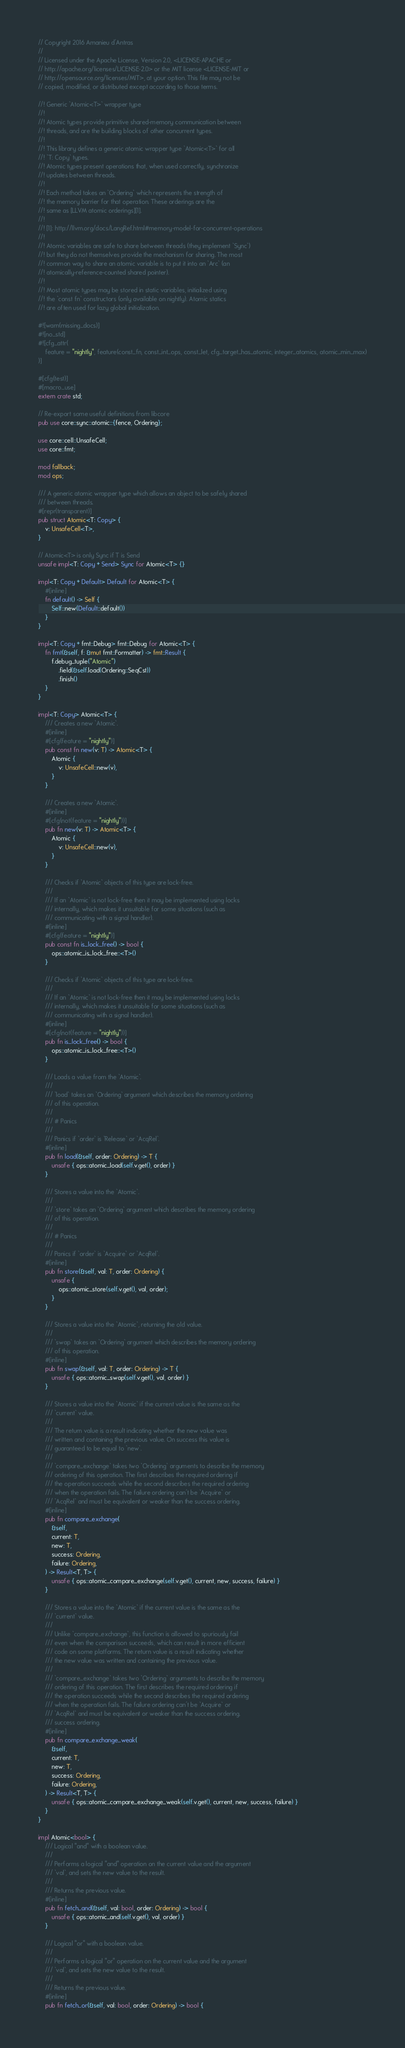<code> <loc_0><loc_0><loc_500><loc_500><_Rust_>// Copyright 2016 Amanieu d'Antras
//
// Licensed under the Apache License, Version 2.0, <LICENSE-APACHE or
// http://apache.org/licenses/LICENSE-2.0> or the MIT license <LICENSE-MIT or
// http://opensource.org/licenses/MIT>, at your option. This file may not be
// copied, modified, or distributed except according to those terms.

//! Generic `Atomic<T>` wrapper type
//!
//! Atomic types provide primitive shared-memory communication between
//! threads, and are the building blocks of other concurrent types.
//!
//! This library defines a generic atomic wrapper type `Atomic<T>` for all
//! `T: Copy` types.
//! Atomic types present operations that, when used correctly, synchronize
//! updates between threads.
//!
//! Each method takes an `Ordering` which represents the strength of
//! the memory barrier for that operation. These orderings are the
//! same as [LLVM atomic orderings][1].
//!
//! [1]: http://llvm.org/docs/LangRef.html#memory-model-for-concurrent-operations
//!
//! Atomic variables are safe to share between threads (they implement `Sync`)
//! but they do not themselves provide the mechanism for sharing. The most
//! common way to share an atomic variable is to put it into an `Arc` (an
//! atomically-reference-counted shared pointer).
//!
//! Most atomic types may be stored in static variables, initialized using
//! the `const fn` constructors (only available on nightly). Atomic statics
//! are often used for lazy global initialization.

#![warn(missing_docs)]
#![no_std]
#![cfg_attr(
    feature = "nightly", feature(const_fn, const_int_ops, const_let, cfg_target_has_atomic, integer_atomics, atomic_min_max)
)]

#[cfg(test)]
#[macro_use]
extern crate std;

// Re-export some useful definitions from libcore
pub use core::sync::atomic::{fence, Ordering};

use core::cell::UnsafeCell;
use core::fmt;

mod fallback;
mod ops;

/// A generic atomic wrapper type which allows an object to be safely shared
/// between threads.
#[repr(transparent)]
pub struct Atomic<T: Copy> {
    v: UnsafeCell<T>,
}

// Atomic<T> is only Sync if T is Send
unsafe impl<T: Copy + Send> Sync for Atomic<T> {}

impl<T: Copy + Default> Default for Atomic<T> {
    #[inline]
    fn default() -> Self {
        Self::new(Default::default())
    }
}

impl<T: Copy + fmt::Debug> fmt::Debug for Atomic<T> {
    fn fmt(&self, f: &mut fmt::Formatter) -> fmt::Result {
        f.debug_tuple("Atomic")
            .field(&self.load(Ordering::SeqCst))
            .finish()
    }
}

impl<T: Copy> Atomic<T> {
    /// Creates a new `Atomic`.
    #[inline]
    #[cfg(feature = "nightly")]
    pub const fn new(v: T) -> Atomic<T> {
        Atomic {
            v: UnsafeCell::new(v),
        }
    }

    /// Creates a new `Atomic`.
    #[inline]
    #[cfg(not(feature = "nightly"))]
    pub fn new(v: T) -> Atomic<T> {
        Atomic {
            v: UnsafeCell::new(v),
        }
    }

    /// Checks if `Atomic` objects of this type are lock-free.
    ///
    /// If an `Atomic` is not lock-free then it may be implemented using locks
    /// internally, which makes it unsuitable for some situations (such as
    /// communicating with a signal handler).
    #[inline]
    #[cfg(feature = "nightly")]
    pub const fn is_lock_free() -> bool {
        ops::atomic_is_lock_free::<T>()
    }

    /// Checks if `Atomic` objects of this type are lock-free.
    ///
    /// If an `Atomic` is not lock-free then it may be implemented using locks
    /// internally, which makes it unsuitable for some situations (such as
    /// communicating with a signal handler).
    #[inline]
    #[cfg(not(feature = "nightly"))]
    pub fn is_lock_free() -> bool {
        ops::atomic_is_lock_free::<T>()
    }

    /// Loads a value from the `Atomic`.
    ///
    /// `load` takes an `Ordering` argument which describes the memory ordering
    /// of this operation.
    ///
    /// # Panics
    ///
    /// Panics if `order` is `Release` or `AcqRel`.
    #[inline]
    pub fn load(&self, order: Ordering) -> T {
        unsafe { ops::atomic_load(self.v.get(), order) }
    }

    /// Stores a value into the `Atomic`.
    ///
    /// `store` takes an `Ordering` argument which describes the memory ordering
    /// of this operation.
    ///
    /// # Panics
    ///
    /// Panics if `order` is `Acquire` or `AcqRel`.
    #[inline]
    pub fn store(&self, val: T, order: Ordering) {
        unsafe {
            ops::atomic_store(self.v.get(), val, order);
        }
    }

    /// Stores a value into the `Atomic`, returning the old value.
    ///
    /// `swap` takes an `Ordering` argument which describes the memory ordering
    /// of this operation.
    #[inline]
    pub fn swap(&self, val: T, order: Ordering) -> T {
        unsafe { ops::atomic_swap(self.v.get(), val, order) }
    }

    /// Stores a value into the `Atomic` if the current value is the same as the
    /// `current` value.
    ///
    /// The return value is a result indicating whether the new value was
    /// written and containing the previous value. On success this value is
    /// guaranteed to be equal to `new`.
    ///
    /// `compare_exchange` takes two `Ordering` arguments to describe the memory
    /// ordering of this operation. The first describes the required ordering if
    /// the operation succeeds while the second describes the required ordering
    /// when the operation fails. The failure ordering can't be `Acquire` or
    /// `AcqRel` and must be equivalent or weaker than the success ordering.
    #[inline]
    pub fn compare_exchange(
        &self,
        current: T,
        new: T,
        success: Ordering,
        failure: Ordering,
    ) -> Result<T, T> {
        unsafe { ops::atomic_compare_exchange(self.v.get(), current, new, success, failure) }
    }

    /// Stores a value into the `Atomic` if the current value is the same as the
    /// `current` value.
    ///
    /// Unlike `compare_exchange`, this function is allowed to spuriously fail
    /// even when the comparison succeeds, which can result in more efficient
    /// code on some platforms. The return value is a result indicating whether
    /// the new value was written and containing the previous value.
    ///
    /// `compare_exchange` takes two `Ordering` arguments to describe the memory
    /// ordering of this operation. The first describes the required ordering if
    /// the operation succeeds while the second describes the required ordering
    /// when the operation fails. The failure ordering can't be `Acquire` or
    /// `AcqRel` and must be equivalent or weaker than the success ordering.
    /// success ordering.
    #[inline]
    pub fn compare_exchange_weak(
        &self,
        current: T,
        new: T,
        success: Ordering,
        failure: Ordering,
    ) -> Result<T, T> {
        unsafe { ops::atomic_compare_exchange_weak(self.v.get(), current, new, success, failure) }
    }
}

impl Atomic<bool> {
    /// Logical "and" with a boolean value.
    ///
    /// Performs a logical "and" operation on the current value and the argument
    /// `val`, and sets the new value to the result.
    ///
    /// Returns the previous value.
    #[inline]
    pub fn fetch_and(&self, val: bool, order: Ordering) -> bool {
        unsafe { ops::atomic_and(self.v.get(), val, order) }
    }

    /// Logical "or" with a boolean value.
    ///
    /// Performs a logical "or" operation on the current value and the argument
    /// `val`, and sets the new value to the result.
    ///
    /// Returns the previous value.
    #[inline]
    pub fn fetch_or(&self, val: bool, order: Ordering) -> bool {</code> 